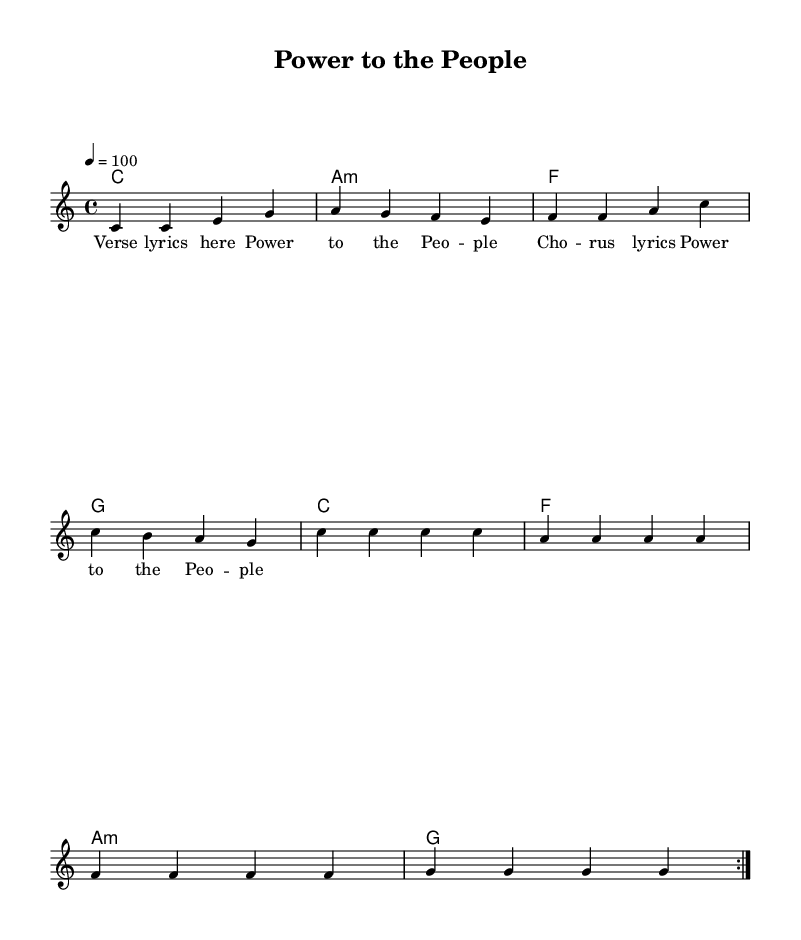What is the key signature of this music? The key signature is C major, which has no sharps or flats.
Answer: C major What is the time signature of this music? The time signature is indicated as 4/4, meaning there are four beats per measure.
Answer: 4/4 What is the tempo marking in this piece? The tempo marking is indicated as 4 = 100, meaning the quarter note gets 100 beats per minute.
Answer: 100 How many measures are in the verse section? The verse section consists of 4 measures, as indicated by the notes before the chorus starts.
Answer: 4 Which chord follows the C major chord in the melody? The chord that follows the C major chord in the harmony is A minor, as seen in the harmonic progression.
Answer: A minor How many times is the chorus repeated in the piece? The chorus is indicated to be repeated once along with the verse, making two total repetitions of the chorus.
Answer: 2 What is the title of the song represented in the sheet music? The title is found at the top of the sheet music, indicated clearly as "Power to the People."
Answer: Power to the People 